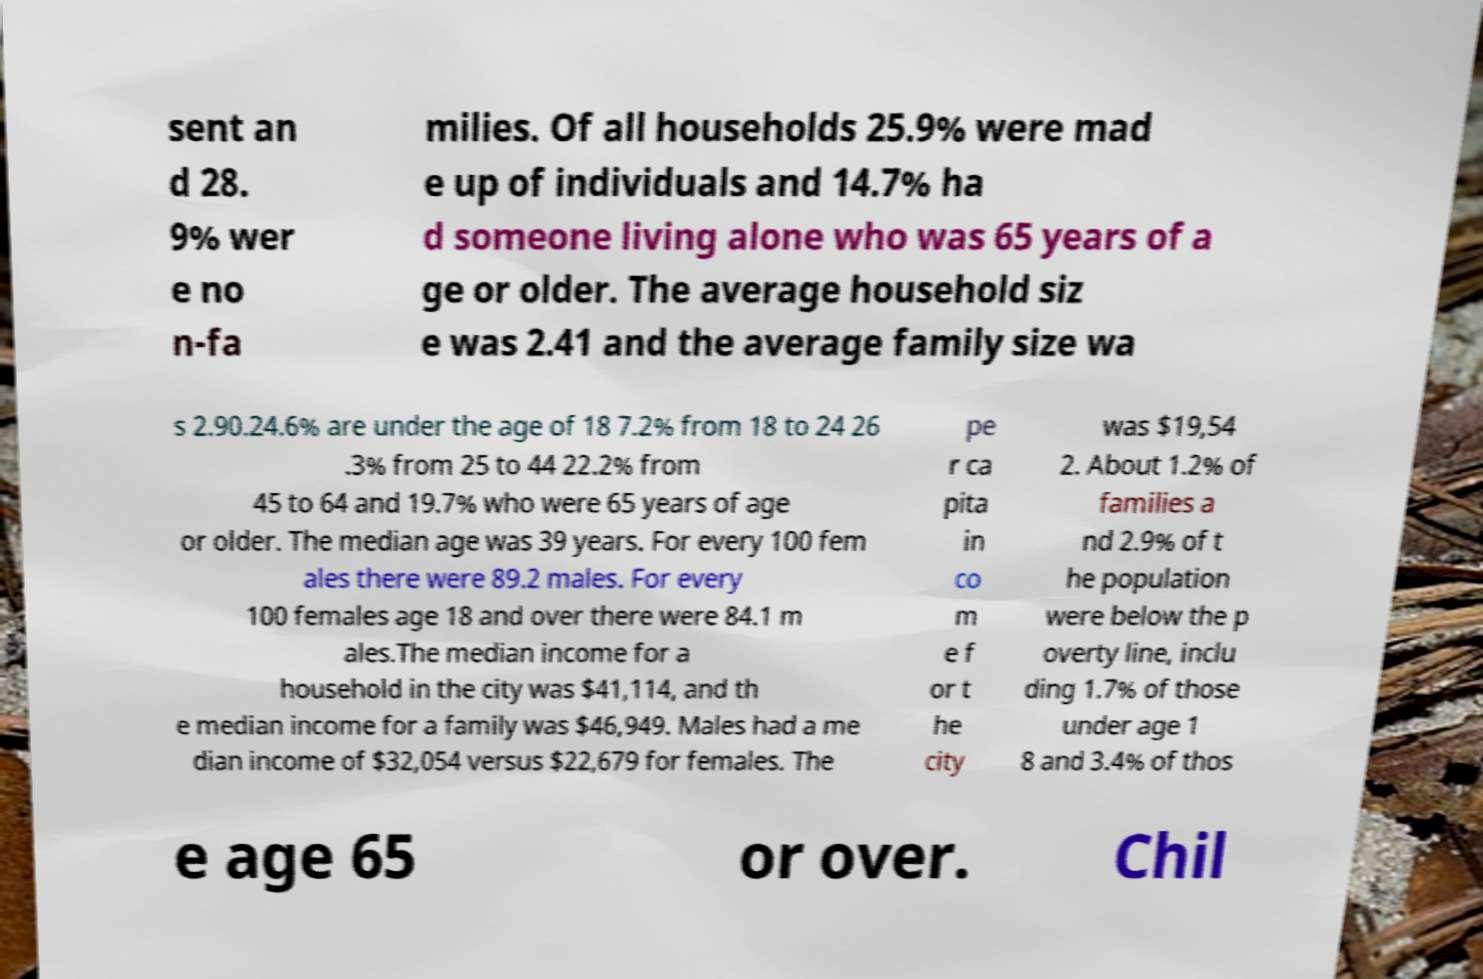What messages or text are displayed in this image? I need them in a readable, typed format. sent an d 28. 9% wer e no n-fa milies. Of all households 25.9% were mad e up of individuals and 14.7% ha d someone living alone who was 65 years of a ge or older. The average household siz e was 2.41 and the average family size wa s 2.90.24.6% are under the age of 18 7.2% from 18 to 24 26 .3% from 25 to 44 22.2% from 45 to 64 and 19.7% who were 65 years of age or older. The median age was 39 years. For every 100 fem ales there were 89.2 males. For every 100 females age 18 and over there were 84.1 m ales.The median income for a household in the city was $41,114, and th e median income for a family was $46,949. Males had a me dian income of $32,054 versus $22,679 for females. The pe r ca pita in co m e f or t he city was $19,54 2. About 1.2% of families a nd 2.9% of t he population were below the p overty line, inclu ding 1.7% of those under age 1 8 and 3.4% of thos e age 65 or over. Chil 